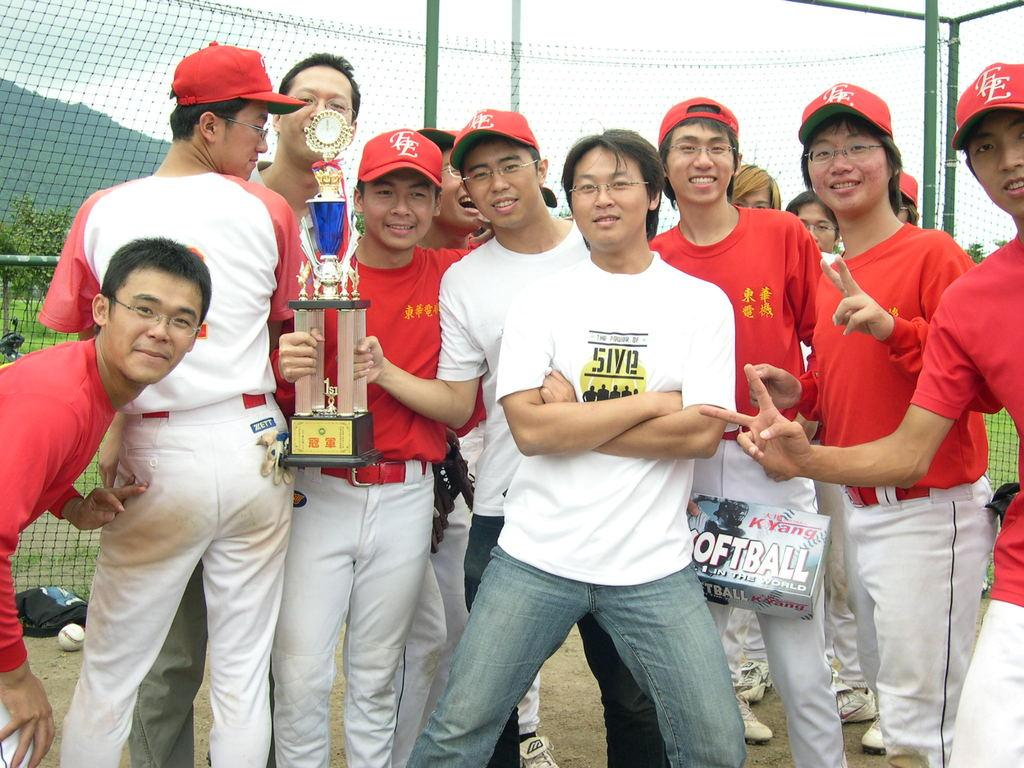Provide a one-sentence caption for the provided image. A man wearing a 5ive t-shirt poses with baseball players. 